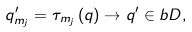<formula> <loc_0><loc_0><loc_500><loc_500>q _ { m _ { j } } ^ { \prime } = \tau _ { m _ { j } } \left ( q \right ) \rightarrow q ^ { \prime } \in b D ,</formula> 